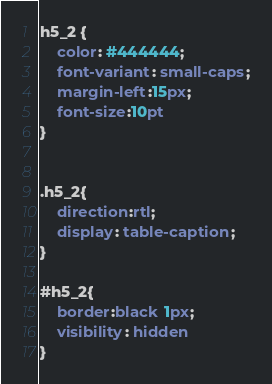<code> <loc_0><loc_0><loc_500><loc_500><_CSS_>h5_2 {
    color: #444444;	
    font-variant: small-caps;
    margin-left:15px;
    font-size:10pt	
}


.h5_2{
    direction:rtl;
    display: table-caption;
}

#h5_2{
    border:black 1px;
    visibility: hidden
}</code> 